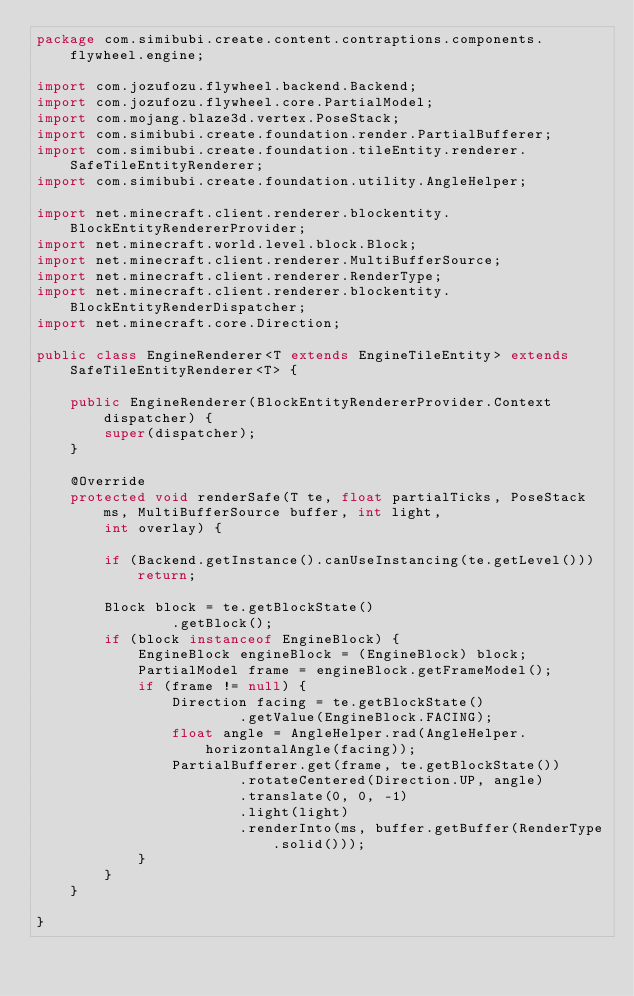<code> <loc_0><loc_0><loc_500><loc_500><_Java_>package com.simibubi.create.content.contraptions.components.flywheel.engine;

import com.jozufozu.flywheel.backend.Backend;
import com.jozufozu.flywheel.core.PartialModel;
import com.mojang.blaze3d.vertex.PoseStack;
import com.simibubi.create.foundation.render.PartialBufferer;
import com.simibubi.create.foundation.tileEntity.renderer.SafeTileEntityRenderer;
import com.simibubi.create.foundation.utility.AngleHelper;

import net.minecraft.client.renderer.blockentity.BlockEntityRendererProvider;
import net.minecraft.world.level.block.Block;
import net.minecraft.client.renderer.MultiBufferSource;
import net.minecraft.client.renderer.RenderType;
import net.minecraft.client.renderer.blockentity.BlockEntityRenderDispatcher;
import net.minecraft.core.Direction;

public class EngineRenderer<T extends EngineTileEntity> extends SafeTileEntityRenderer<T> {

	public EngineRenderer(BlockEntityRendererProvider.Context dispatcher) {
		super(dispatcher);
	}

	@Override
	protected void renderSafe(T te, float partialTicks, PoseStack ms, MultiBufferSource buffer, int light,
		int overlay) {

		if (Backend.getInstance().canUseInstancing(te.getLevel())) return;

		Block block = te.getBlockState()
				.getBlock();
		if (block instanceof EngineBlock) {
			EngineBlock engineBlock = (EngineBlock) block;
			PartialModel frame = engineBlock.getFrameModel();
			if (frame != null) {
				Direction facing = te.getBlockState()
						.getValue(EngineBlock.FACING);
				float angle = AngleHelper.rad(AngleHelper.horizontalAngle(facing));
				PartialBufferer.get(frame, te.getBlockState())
						.rotateCentered(Direction.UP, angle)
						.translate(0, 0, -1)
						.light(light)
						.renderInto(ms, buffer.getBuffer(RenderType.solid()));
			}
		}
	}

}
</code> 